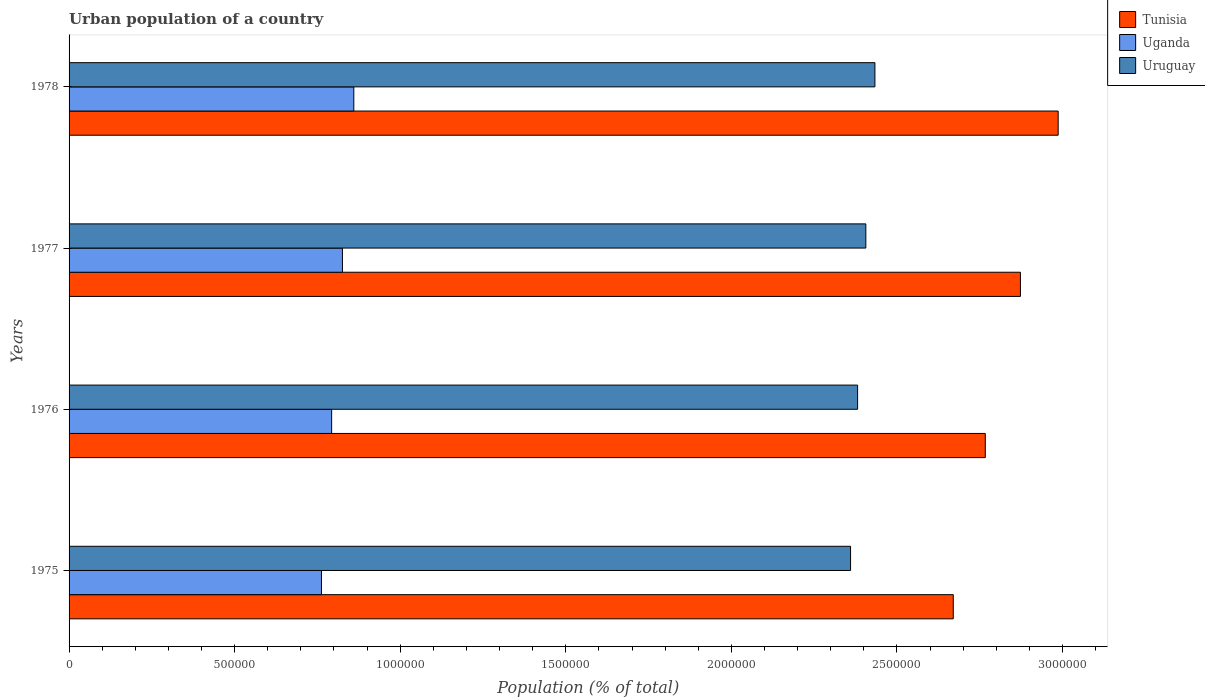How many different coloured bars are there?
Offer a very short reply. 3. How many bars are there on the 3rd tick from the top?
Provide a short and direct response. 3. What is the label of the 1st group of bars from the top?
Offer a terse response. 1978. What is the urban population in Tunisia in 1978?
Make the answer very short. 2.99e+06. Across all years, what is the maximum urban population in Tunisia?
Give a very brief answer. 2.99e+06. Across all years, what is the minimum urban population in Uganda?
Your response must be concise. 7.62e+05. In which year was the urban population in Tunisia maximum?
Offer a very short reply. 1978. In which year was the urban population in Uruguay minimum?
Make the answer very short. 1975. What is the total urban population in Uruguay in the graph?
Your answer should be very brief. 9.58e+06. What is the difference between the urban population in Tunisia in 1975 and that in 1976?
Your answer should be very brief. -9.67e+04. What is the difference between the urban population in Tunisia in 1977 and the urban population in Uganda in 1975?
Make the answer very short. 2.11e+06. What is the average urban population in Uganda per year?
Provide a succinct answer. 8.10e+05. In the year 1978, what is the difference between the urban population in Tunisia and urban population in Uruguay?
Ensure brevity in your answer.  5.53e+05. In how many years, is the urban population in Uruguay greater than 2500000 %?
Keep it short and to the point. 0. What is the ratio of the urban population in Tunisia in 1975 to that in 1976?
Keep it short and to the point. 0.97. Is the urban population in Uruguay in 1975 less than that in 1978?
Offer a terse response. Yes. Is the difference between the urban population in Tunisia in 1976 and 1978 greater than the difference between the urban population in Uruguay in 1976 and 1978?
Give a very brief answer. No. What is the difference between the highest and the second highest urban population in Uganda?
Offer a very short reply. 3.43e+04. What is the difference between the highest and the lowest urban population in Tunisia?
Provide a short and direct response. 3.17e+05. What does the 2nd bar from the top in 1976 represents?
Your answer should be very brief. Uganda. What does the 2nd bar from the bottom in 1975 represents?
Your answer should be very brief. Uganda. Is it the case that in every year, the sum of the urban population in Tunisia and urban population in Uruguay is greater than the urban population in Uganda?
Your response must be concise. Yes. How many bars are there?
Ensure brevity in your answer.  12. Are the values on the major ticks of X-axis written in scientific E-notation?
Your response must be concise. No. Does the graph contain any zero values?
Your answer should be very brief. No. Does the graph contain grids?
Your answer should be compact. No. How many legend labels are there?
Ensure brevity in your answer.  3. What is the title of the graph?
Ensure brevity in your answer.  Urban population of a country. What is the label or title of the X-axis?
Offer a very short reply. Population (% of total). What is the label or title of the Y-axis?
Provide a succinct answer. Years. What is the Population (% of total) of Tunisia in 1975?
Keep it short and to the point. 2.67e+06. What is the Population (% of total) of Uganda in 1975?
Provide a succinct answer. 7.62e+05. What is the Population (% of total) in Uruguay in 1975?
Offer a very short reply. 2.36e+06. What is the Population (% of total) of Tunisia in 1976?
Give a very brief answer. 2.77e+06. What is the Population (% of total) of Uganda in 1976?
Give a very brief answer. 7.93e+05. What is the Population (% of total) of Uruguay in 1976?
Your answer should be very brief. 2.38e+06. What is the Population (% of total) in Tunisia in 1977?
Your response must be concise. 2.87e+06. What is the Population (% of total) of Uganda in 1977?
Offer a terse response. 8.26e+05. What is the Population (% of total) in Uruguay in 1977?
Provide a succinct answer. 2.41e+06. What is the Population (% of total) in Tunisia in 1978?
Make the answer very short. 2.99e+06. What is the Population (% of total) of Uganda in 1978?
Keep it short and to the point. 8.60e+05. What is the Population (% of total) in Uruguay in 1978?
Ensure brevity in your answer.  2.43e+06. Across all years, what is the maximum Population (% of total) of Tunisia?
Provide a short and direct response. 2.99e+06. Across all years, what is the maximum Population (% of total) of Uganda?
Provide a short and direct response. 8.60e+05. Across all years, what is the maximum Population (% of total) in Uruguay?
Your answer should be very brief. 2.43e+06. Across all years, what is the minimum Population (% of total) in Tunisia?
Offer a very short reply. 2.67e+06. Across all years, what is the minimum Population (% of total) in Uganda?
Keep it short and to the point. 7.62e+05. Across all years, what is the minimum Population (% of total) of Uruguay?
Your answer should be very brief. 2.36e+06. What is the total Population (% of total) of Tunisia in the graph?
Keep it short and to the point. 1.13e+07. What is the total Population (% of total) of Uganda in the graph?
Make the answer very short. 3.24e+06. What is the total Population (% of total) of Uruguay in the graph?
Make the answer very short. 9.58e+06. What is the difference between the Population (% of total) of Tunisia in 1975 and that in 1976?
Your answer should be very brief. -9.67e+04. What is the difference between the Population (% of total) of Uganda in 1975 and that in 1976?
Offer a terse response. -3.07e+04. What is the difference between the Population (% of total) in Uruguay in 1975 and that in 1976?
Ensure brevity in your answer.  -2.13e+04. What is the difference between the Population (% of total) of Tunisia in 1975 and that in 1977?
Offer a very short reply. -2.03e+05. What is the difference between the Population (% of total) of Uganda in 1975 and that in 1977?
Keep it short and to the point. -6.33e+04. What is the difference between the Population (% of total) in Uruguay in 1975 and that in 1977?
Your response must be concise. -4.61e+04. What is the difference between the Population (% of total) in Tunisia in 1975 and that in 1978?
Make the answer very short. -3.17e+05. What is the difference between the Population (% of total) of Uganda in 1975 and that in 1978?
Your response must be concise. -9.76e+04. What is the difference between the Population (% of total) in Uruguay in 1975 and that in 1978?
Offer a terse response. -7.35e+04. What is the difference between the Population (% of total) of Tunisia in 1976 and that in 1977?
Give a very brief answer. -1.06e+05. What is the difference between the Population (% of total) in Uganda in 1976 and that in 1977?
Make the answer very short. -3.26e+04. What is the difference between the Population (% of total) of Uruguay in 1976 and that in 1977?
Ensure brevity in your answer.  -2.48e+04. What is the difference between the Population (% of total) in Tunisia in 1976 and that in 1978?
Offer a terse response. -2.20e+05. What is the difference between the Population (% of total) of Uganda in 1976 and that in 1978?
Offer a terse response. -6.69e+04. What is the difference between the Population (% of total) of Uruguay in 1976 and that in 1978?
Keep it short and to the point. -5.22e+04. What is the difference between the Population (% of total) of Tunisia in 1977 and that in 1978?
Keep it short and to the point. -1.14e+05. What is the difference between the Population (% of total) of Uganda in 1977 and that in 1978?
Make the answer very short. -3.43e+04. What is the difference between the Population (% of total) of Uruguay in 1977 and that in 1978?
Offer a terse response. -2.74e+04. What is the difference between the Population (% of total) of Tunisia in 1975 and the Population (% of total) of Uganda in 1976?
Provide a succinct answer. 1.88e+06. What is the difference between the Population (% of total) of Tunisia in 1975 and the Population (% of total) of Uruguay in 1976?
Offer a terse response. 2.89e+05. What is the difference between the Population (% of total) of Uganda in 1975 and the Population (% of total) of Uruguay in 1976?
Provide a short and direct response. -1.62e+06. What is the difference between the Population (% of total) in Tunisia in 1975 and the Population (% of total) in Uganda in 1977?
Provide a short and direct response. 1.84e+06. What is the difference between the Population (% of total) of Tunisia in 1975 and the Population (% of total) of Uruguay in 1977?
Keep it short and to the point. 2.64e+05. What is the difference between the Population (% of total) in Uganda in 1975 and the Population (% of total) in Uruguay in 1977?
Your answer should be very brief. -1.64e+06. What is the difference between the Population (% of total) of Tunisia in 1975 and the Population (% of total) of Uganda in 1978?
Give a very brief answer. 1.81e+06. What is the difference between the Population (% of total) of Tunisia in 1975 and the Population (% of total) of Uruguay in 1978?
Provide a succinct answer. 2.37e+05. What is the difference between the Population (% of total) in Uganda in 1975 and the Population (% of total) in Uruguay in 1978?
Your answer should be very brief. -1.67e+06. What is the difference between the Population (% of total) in Tunisia in 1976 and the Population (% of total) in Uganda in 1977?
Provide a short and direct response. 1.94e+06. What is the difference between the Population (% of total) in Tunisia in 1976 and the Population (% of total) in Uruguay in 1977?
Offer a very short reply. 3.61e+05. What is the difference between the Population (% of total) of Uganda in 1976 and the Population (% of total) of Uruguay in 1977?
Your answer should be very brief. -1.61e+06. What is the difference between the Population (% of total) of Tunisia in 1976 and the Population (% of total) of Uganda in 1978?
Provide a succinct answer. 1.91e+06. What is the difference between the Population (% of total) in Tunisia in 1976 and the Population (% of total) in Uruguay in 1978?
Provide a short and direct response. 3.33e+05. What is the difference between the Population (% of total) of Uganda in 1976 and the Population (% of total) of Uruguay in 1978?
Provide a short and direct response. -1.64e+06. What is the difference between the Population (% of total) of Tunisia in 1977 and the Population (% of total) of Uganda in 1978?
Provide a succinct answer. 2.01e+06. What is the difference between the Population (% of total) in Tunisia in 1977 and the Population (% of total) in Uruguay in 1978?
Ensure brevity in your answer.  4.39e+05. What is the difference between the Population (% of total) in Uganda in 1977 and the Population (% of total) in Uruguay in 1978?
Your answer should be compact. -1.61e+06. What is the average Population (% of total) in Tunisia per year?
Your response must be concise. 2.82e+06. What is the average Population (% of total) in Uganda per year?
Make the answer very short. 8.10e+05. What is the average Population (% of total) of Uruguay per year?
Give a very brief answer. 2.40e+06. In the year 1975, what is the difference between the Population (% of total) of Tunisia and Population (% of total) of Uganda?
Make the answer very short. 1.91e+06. In the year 1975, what is the difference between the Population (% of total) in Tunisia and Population (% of total) in Uruguay?
Provide a succinct answer. 3.10e+05. In the year 1975, what is the difference between the Population (% of total) of Uganda and Population (% of total) of Uruguay?
Offer a terse response. -1.60e+06. In the year 1976, what is the difference between the Population (% of total) in Tunisia and Population (% of total) in Uganda?
Ensure brevity in your answer.  1.97e+06. In the year 1976, what is the difference between the Population (% of total) of Tunisia and Population (% of total) of Uruguay?
Provide a succinct answer. 3.86e+05. In the year 1976, what is the difference between the Population (% of total) of Uganda and Population (% of total) of Uruguay?
Your response must be concise. -1.59e+06. In the year 1977, what is the difference between the Population (% of total) in Tunisia and Population (% of total) in Uganda?
Make the answer very short. 2.05e+06. In the year 1977, what is the difference between the Population (% of total) of Tunisia and Population (% of total) of Uruguay?
Provide a short and direct response. 4.67e+05. In the year 1977, what is the difference between the Population (% of total) of Uganda and Population (% of total) of Uruguay?
Keep it short and to the point. -1.58e+06. In the year 1978, what is the difference between the Population (% of total) of Tunisia and Population (% of total) of Uganda?
Offer a very short reply. 2.13e+06. In the year 1978, what is the difference between the Population (% of total) in Tunisia and Population (% of total) in Uruguay?
Offer a very short reply. 5.53e+05. In the year 1978, what is the difference between the Population (% of total) in Uganda and Population (% of total) in Uruguay?
Your response must be concise. -1.57e+06. What is the ratio of the Population (% of total) in Tunisia in 1975 to that in 1976?
Offer a terse response. 0.96. What is the ratio of the Population (% of total) of Uganda in 1975 to that in 1976?
Make the answer very short. 0.96. What is the ratio of the Population (% of total) of Tunisia in 1975 to that in 1977?
Make the answer very short. 0.93. What is the ratio of the Population (% of total) in Uganda in 1975 to that in 1977?
Offer a terse response. 0.92. What is the ratio of the Population (% of total) of Uruguay in 1975 to that in 1977?
Give a very brief answer. 0.98. What is the ratio of the Population (% of total) in Tunisia in 1975 to that in 1978?
Your response must be concise. 0.89. What is the ratio of the Population (% of total) of Uganda in 1975 to that in 1978?
Offer a terse response. 0.89. What is the ratio of the Population (% of total) of Uruguay in 1975 to that in 1978?
Your answer should be very brief. 0.97. What is the ratio of the Population (% of total) of Tunisia in 1976 to that in 1977?
Provide a short and direct response. 0.96. What is the ratio of the Population (% of total) in Uganda in 1976 to that in 1977?
Offer a terse response. 0.96. What is the ratio of the Population (% of total) of Tunisia in 1976 to that in 1978?
Offer a terse response. 0.93. What is the ratio of the Population (% of total) of Uganda in 1976 to that in 1978?
Offer a very short reply. 0.92. What is the ratio of the Population (% of total) in Uruguay in 1976 to that in 1978?
Your response must be concise. 0.98. What is the ratio of the Population (% of total) of Tunisia in 1977 to that in 1978?
Ensure brevity in your answer.  0.96. What is the ratio of the Population (% of total) in Uganda in 1977 to that in 1978?
Your answer should be compact. 0.96. What is the ratio of the Population (% of total) of Uruguay in 1977 to that in 1978?
Your answer should be compact. 0.99. What is the difference between the highest and the second highest Population (% of total) in Tunisia?
Provide a succinct answer. 1.14e+05. What is the difference between the highest and the second highest Population (% of total) of Uganda?
Your response must be concise. 3.43e+04. What is the difference between the highest and the second highest Population (% of total) of Uruguay?
Make the answer very short. 2.74e+04. What is the difference between the highest and the lowest Population (% of total) of Tunisia?
Offer a very short reply. 3.17e+05. What is the difference between the highest and the lowest Population (% of total) of Uganda?
Give a very brief answer. 9.76e+04. What is the difference between the highest and the lowest Population (% of total) of Uruguay?
Give a very brief answer. 7.35e+04. 